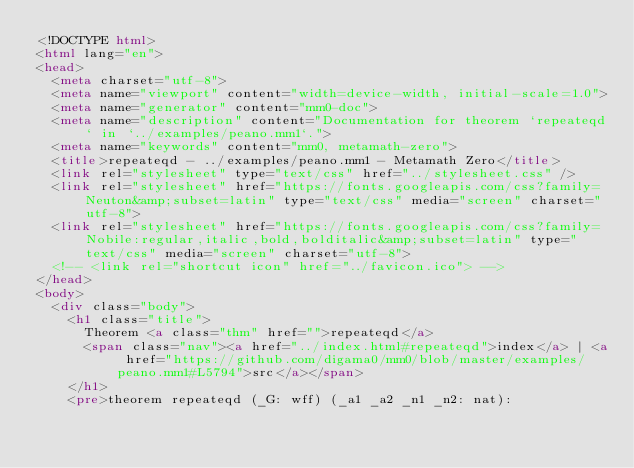<code> <loc_0><loc_0><loc_500><loc_500><_HTML_><!DOCTYPE html>
<html lang="en">
<head>
  <meta charset="utf-8">
  <meta name="viewport" content="width=device-width, initial-scale=1.0">
  <meta name="generator" content="mm0-doc">
  <meta name="description" content="Documentation for theorem `repeateqd` in `../examples/peano.mm1`.">
  <meta name="keywords" content="mm0, metamath-zero">
  <title>repeateqd - ../examples/peano.mm1 - Metamath Zero</title>
  <link rel="stylesheet" type="text/css" href="../stylesheet.css" />
  <link rel="stylesheet" href="https://fonts.googleapis.com/css?family=Neuton&amp;subset=latin" type="text/css" media="screen" charset="utf-8">
  <link rel="stylesheet" href="https://fonts.googleapis.com/css?family=Nobile:regular,italic,bold,bolditalic&amp;subset=latin" type="text/css" media="screen" charset="utf-8">
  <!-- <link rel="shortcut icon" href="../favicon.ico"> -->
</head>
<body>
  <div class="body">
    <h1 class="title">
      Theorem <a class="thm" href="">repeateqd</a>
      <span class="nav"><a href="../index.html#repeateqd">index</a> | <a href="https://github.com/digama0/mm0/blob/master/examples/peano.mm1#L5794">src</a></span>
    </h1>
    <pre>theorem repeateqd (_G: wff) (_a1 _a2 _n1 _n2: nat):</code> 